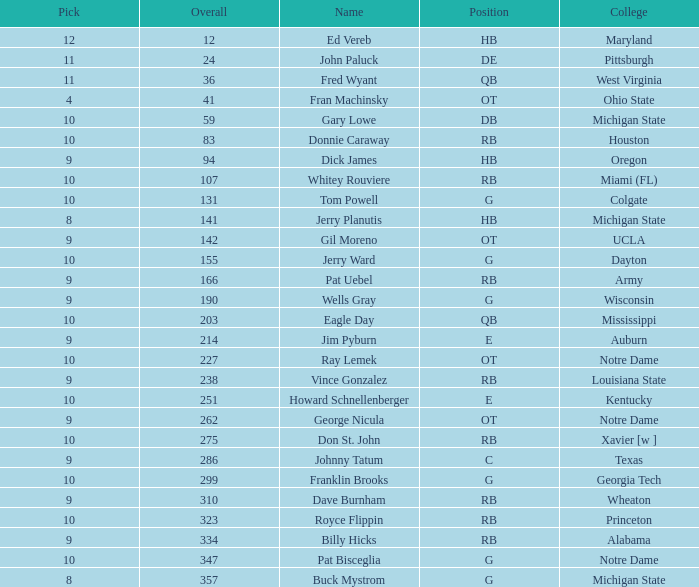For george nicula, what is the greatest overall draft pick number, given that his pick was less than 9? None. 